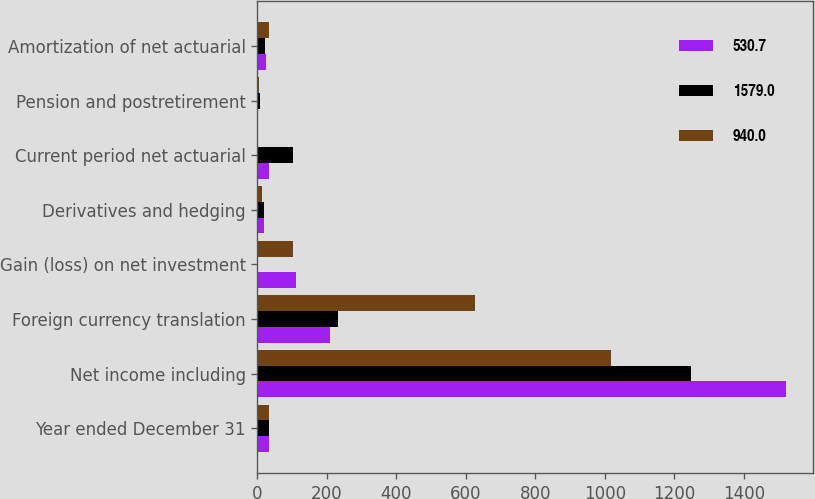Convert chart. <chart><loc_0><loc_0><loc_500><loc_500><stacked_bar_chart><ecel><fcel>Year ended December 31<fcel>Net income including<fcel>Foreign currency translation<fcel>Gain (loss) on net investment<fcel>Derivatives and hedging<fcel>Current period net actuarial<fcel>Pension and postretirement<fcel>Amortization of net actuarial<nl><fcel>530.7<fcel>33.4<fcel>1522.4<fcel>209.1<fcel>109.7<fcel>17.9<fcel>33.4<fcel>0.5<fcel>24.7<nl><fcel>1579<fcel>33.4<fcel>1247.1<fcel>230.4<fcel>2.5<fcel>17.5<fcel>102.3<fcel>7.7<fcel>20.2<nl><fcel>940<fcel>33.4<fcel>1017.2<fcel>626.8<fcel>101.3<fcel>11.7<fcel>2.3<fcel>4.5<fcel>33.6<nl></chart> 